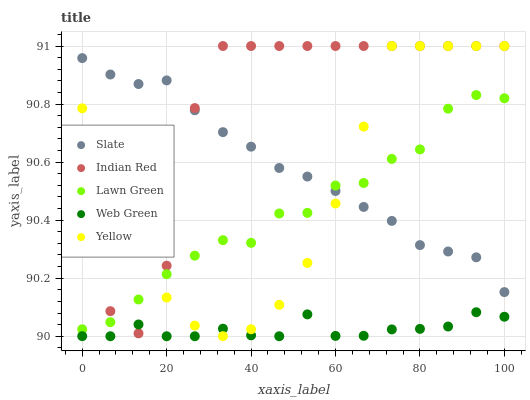Does Web Green have the minimum area under the curve?
Answer yes or no. Yes. Does Indian Red have the maximum area under the curve?
Answer yes or no. Yes. Does Slate have the minimum area under the curve?
Answer yes or no. No. Does Slate have the maximum area under the curve?
Answer yes or no. No. Is Slate the smoothest?
Answer yes or no. Yes. Is Indian Red the roughest?
Answer yes or no. Yes. Is Yellow the smoothest?
Answer yes or no. No. Is Yellow the roughest?
Answer yes or no. No. Does Web Green have the lowest value?
Answer yes or no. Yes. Does Yellow have the lowest value?
Answer yes or no. No. Does Indian Red have the highest value?
Answer yes or no. Yes. Does Slate have the highest value?
Answer yes or no. No. Is Web Green less than Slate?
Answer yes or no. Yes. Is Slate greater than Web Green?
Answer yes or no. Yes. Does Indian Red intersect Yellow?
Answer yes or no. Yes. Is Indian Red less than Yellow?
Answer yes or no. No. Is Indian Red greater than Yellow?
Answer yes or no. No. Does Web Green intersect Slate?
Answer yes or no. No. 